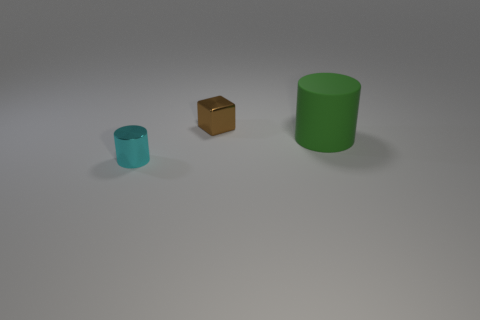Add 1 small cyan objects. How many objects exist? 4 Subtract all blocks. How many objects are left? 2 Subtract 0 red spheres. How many objects are left? 3 Subtract all tiny brown shiny objects. Subtract all large purple rubber things. How many objects are left? 2 Add 1 matte cylinders. How many matte cylinders are left? 2 Add 2 tiny cyan cylinders. How many tiny cyan cylinders exist? 3 